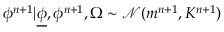<formula> <loc_0><loc_0><loc_500><loc_500>{ { \phi } ^ { n + 1 } } | { \underline { \phi } } , { { \phi } ^ { n + 1 } } , \Omega \sim \mathcal { N } ( m ^ { n + 1 } , K ^ { n + 1 } )</formula> 